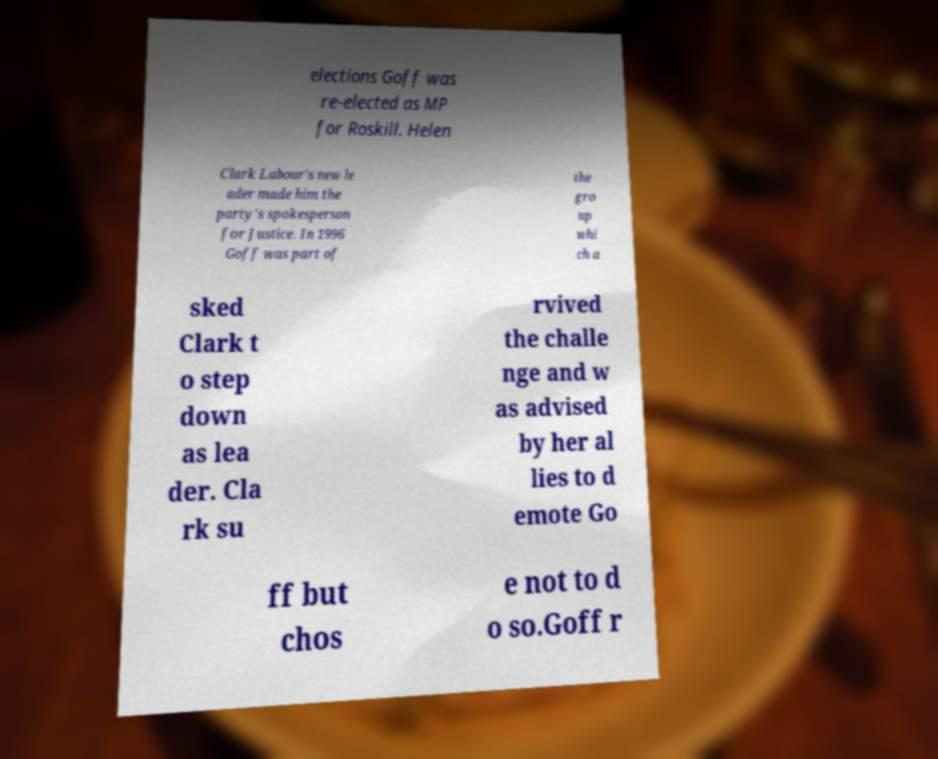Please identify and transcribe the text found in this image. elections Goff was re-elected as MP for Roskill. Helen Clark Labour's new le ader made him the party's spokesperson for Justice. In 1996 Goff was part of the gro up whi ch a sked Clark t o step down as lea der. Cla rk su rvived the challe nge and w as advised by her al lies to d emote Go ff but chos e not to d o so.Goff r 